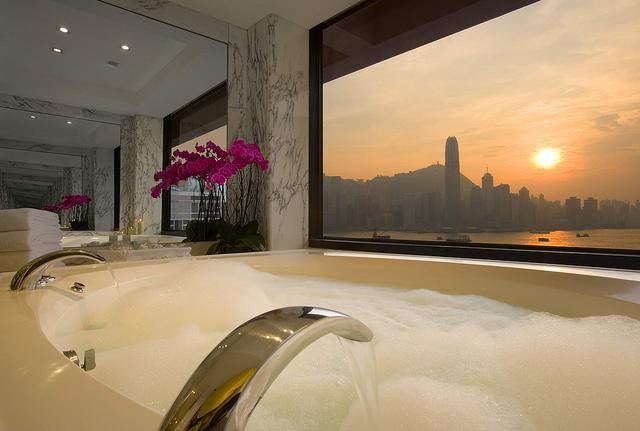What kind of lighting is in this room?
Write a very short answer. Recessed. Roughly how close to capacity is the bathtub filled?
Keep it brief. 75%. What color are the flowers in the room?
Write a very short answer. Pink. 